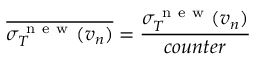<formula> <loc_0><loc_0><loc_500><loc_500>\overline { { \sigma _ { T } ^ { n e w } ( v _ { n } ) } } = \frac { \sigma _ { T } ^ { n e w } ( v _ { n } ) } { c o u n t e r }</formula> 